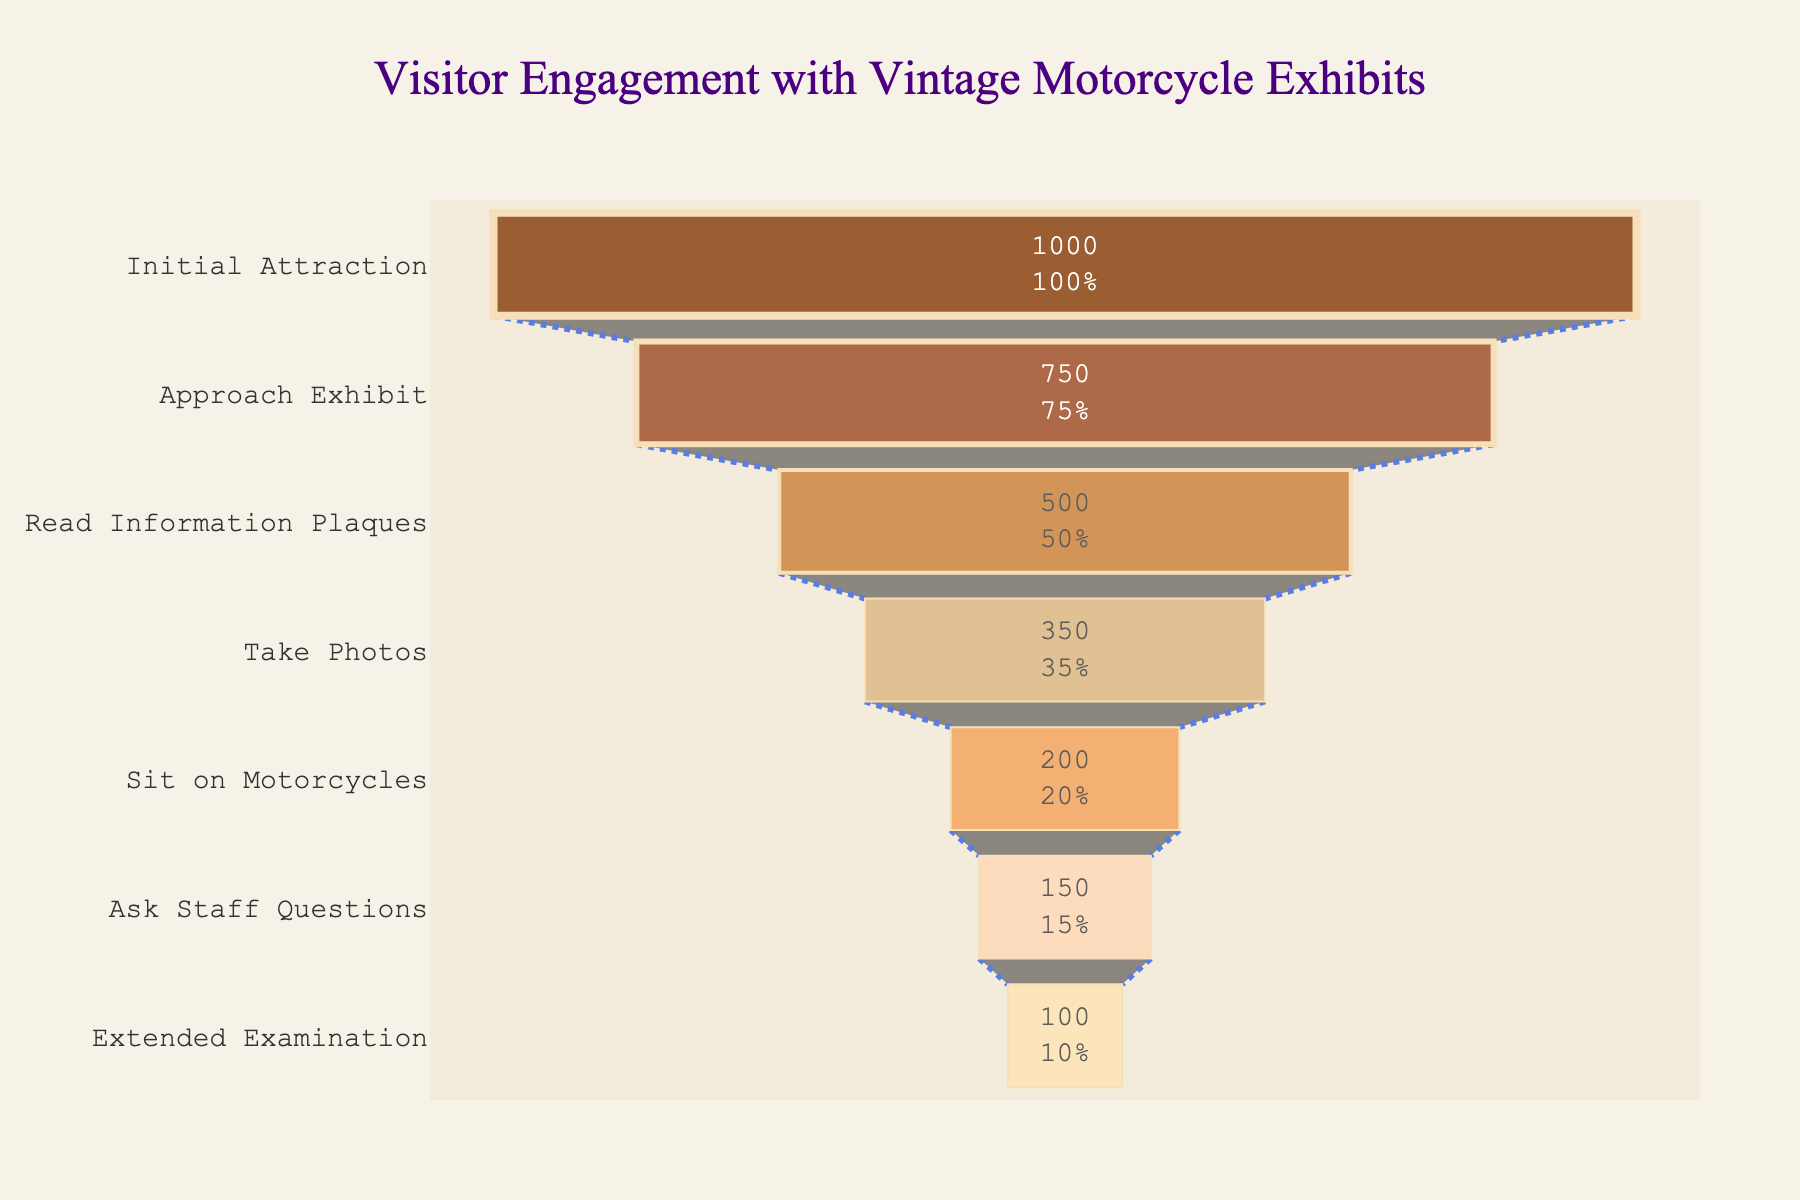How many stages are represented in the chart? The chart illustrates different stages from 'Initial Attraction' to 'Extended Examination'. Count the total stages listed on the vertical axis.
Answer: 7 What is the title of the chart? Identify the text displayed at the top center of the chart.
Answer: Visitor Engagement with Vintage Motorcycle Exhibits What percentage of visitors sit on the motorcycles relative to the initial attraction? The chart shows a value of 200 visitors sitting on motorcycles out of 1000 initially attracted. Calculating this percentage: (200/1000) * 100
Answer: 20% What is the difference in the number of visitors between 'Read Information Plaques' and 'Sit on Motorcycles' stages? Subtract the number of visitors in the 'Sit on Motorcycles' stage from those in the 'Read Information Plaques' stage (500 - 200).
Answer: 300 Which stage has the largest drop in visitors? Assess the reduction in visitor numbers between consecutive stages and identify the pair with the greatest difference. The largest drop is between 'Initial Attraction' (1000) and 'Approach Exhibit' (750), a difference of 250 visitors.
Answer: Initial Attraction to Approach Exhibit How many visitors transition from 'Take Photos' to 'Ask Staff Questions'? Look at the figures for both 'Take Photos' and 'Ask Staff Questions' stages. The number of visitors transitioning is calculated as the difference between these stages (350 - 150).
Answer: 200 What is the color scheme of the bars in the chart? Identify the color progression used in the funnel chart, ranging from shades of brown to lighter beige tones.
Answer: Shades of brown and beige What percentage of visitors engage in 'Extended Examination' relative to those who 'Take Photos'? Calculate the percentage by dividing the number of visitors in 'Extended Examination' (100) by those who 'Take Photos' (350) and multiplying by 100.
Answer: ~28.6% How much does visitor interaction decrease from 'Approach Exhibit' to 'Read Information Plaques'? Subtract the visitors at 'Read Information Plaques' (500) from the visitors at 'Approach Exhibit' (750).
Answer: 250 Which two stages have the smallest numerical difference in visitor count? Compare the differences in visitor count between each pair of consecutive stages. The smallest difference here is between 'Ask Staff Questions' (150) and 'Extended Examination' (100), a difference of 50 visitors.
Answer: Ask Staff Questions to Extended Examination 